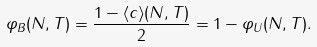Convert formula to latex. <formula><loc_0><loc_0><loc_500><loc_500>\varphi _ { B } ( N , T ) = \frac { 1 - \langle c \rangle ( N , T ) } 2 = 1 - \varphi _ { U } ( N , T ) .</formula> 